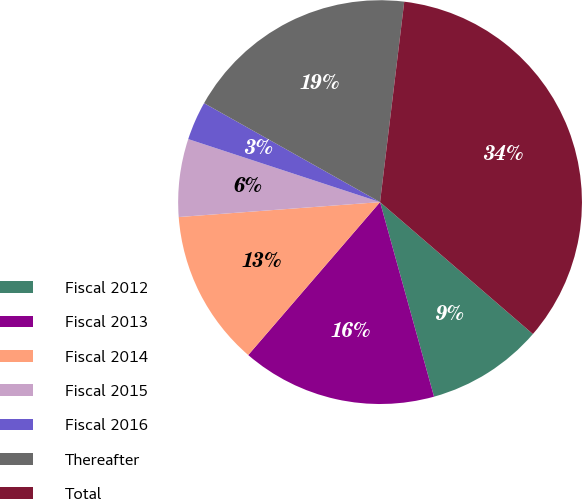Convert chart to OTSL. <chart><loc_0><loc_0><loc_500><loc_500><pie_chart><fcel>Fiscal 2012<fcel>Fiscal 2013<fcel>Fiscal 2014<fcel>Fiscal 2015<fcel>Fiscal 2016<fcel>Thereafter<fcel>Total<nl><fcel>9.36%<fcel>15.63%<fcel>12.5%<fcel>6.23%<fcel>3.1%<fcel>18.76%<fcel>34.42%<nl></chart> 